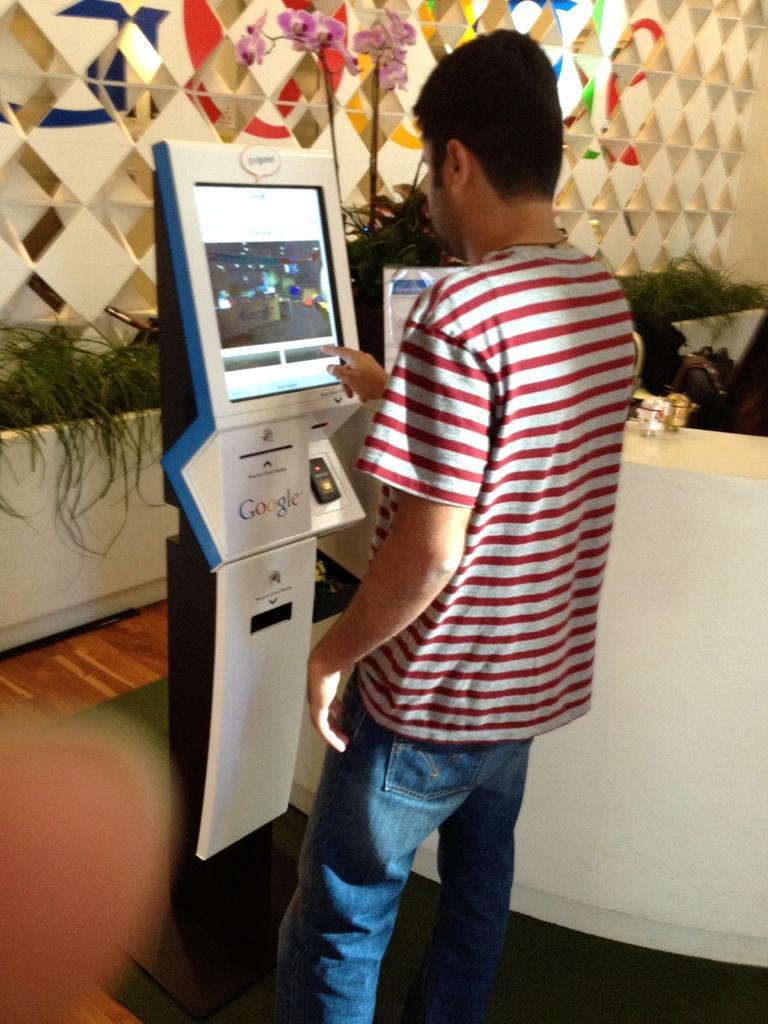Could you give a brief overview of what you see in this image? In this picture there is a man in the center of the image, there is a vending machine in front of him and there are plants and a desk in the background area of the image, there is a decorated wall in the background area of the image. 